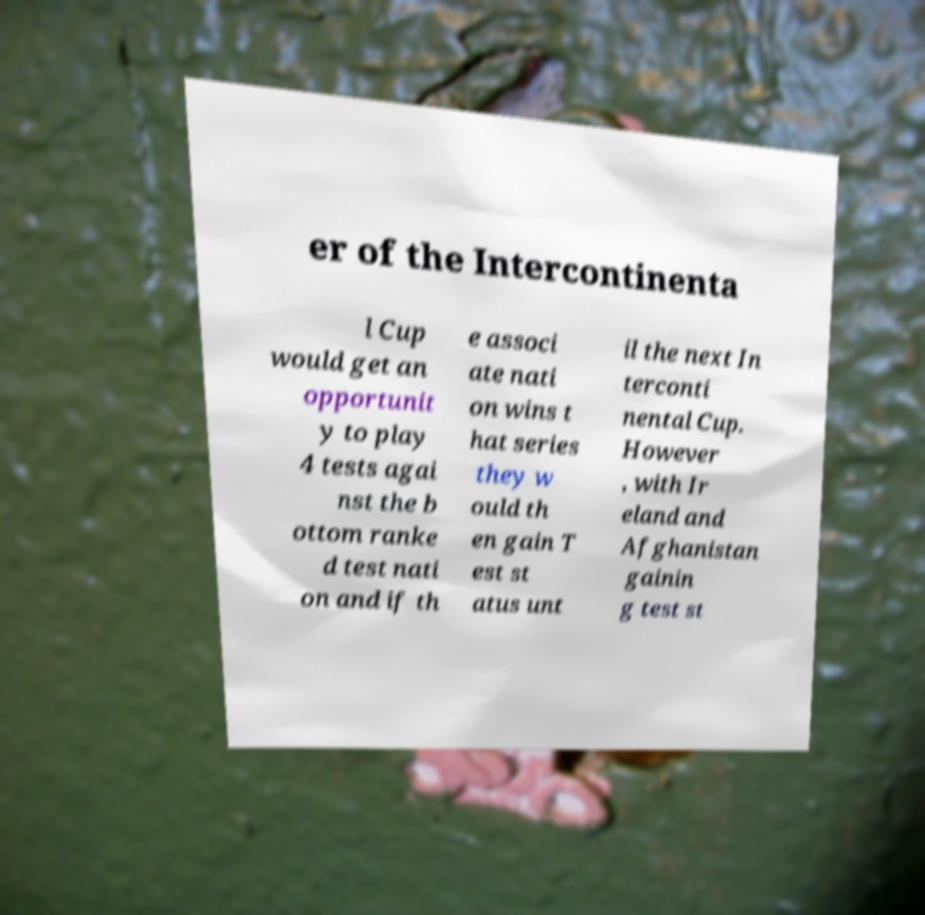Can you read and provide the text displayed in the image?This photo seems to have some interesting text. Can you extract and type it out for me? er of the Intercontinenta l Cup would get an opportunit y to play 4 tests agai nst the b ottom ranke d test nati on and if th e associ ate nati on wins t hat series they w ould th en gain T est st atus unt il the next In terconti nental Cup. However , with Ir eland and Afghanistan gainin g test st 